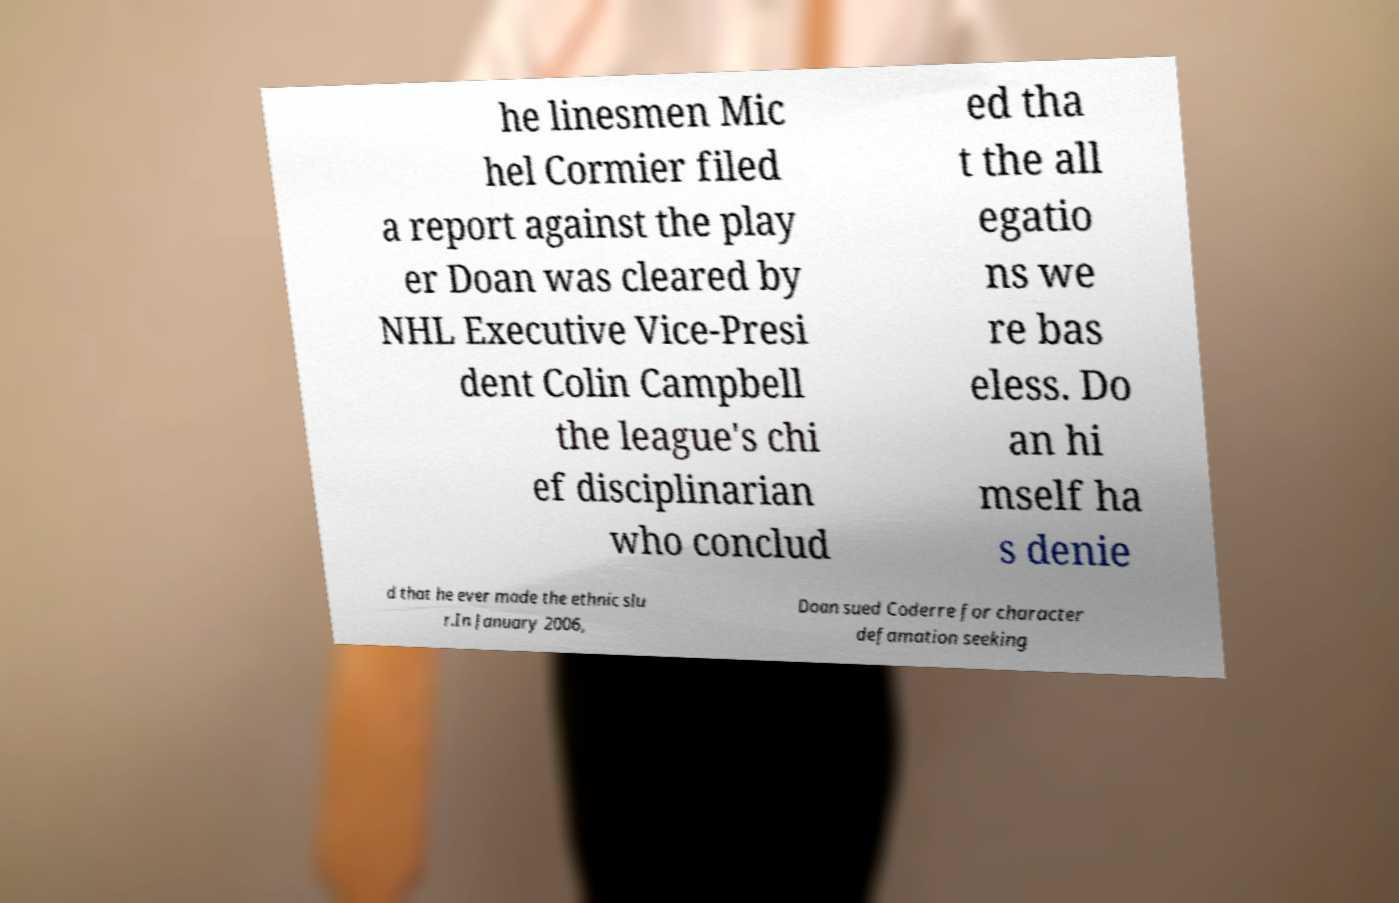Could you extract and type out the text from this image? he linesmen Mic hel Cormier filed a report against the play er Doan was cleared by NHL Executive Vice-Presi dent Colin Campbell the league's chi ef disciplinarian who conclud ed tha t the all egatio ns we re bas eless. Do an hi mself ha s denie d that he ever made the ethnic slu r.In January 2006, Doan sued Coderre for character defamation seeking 